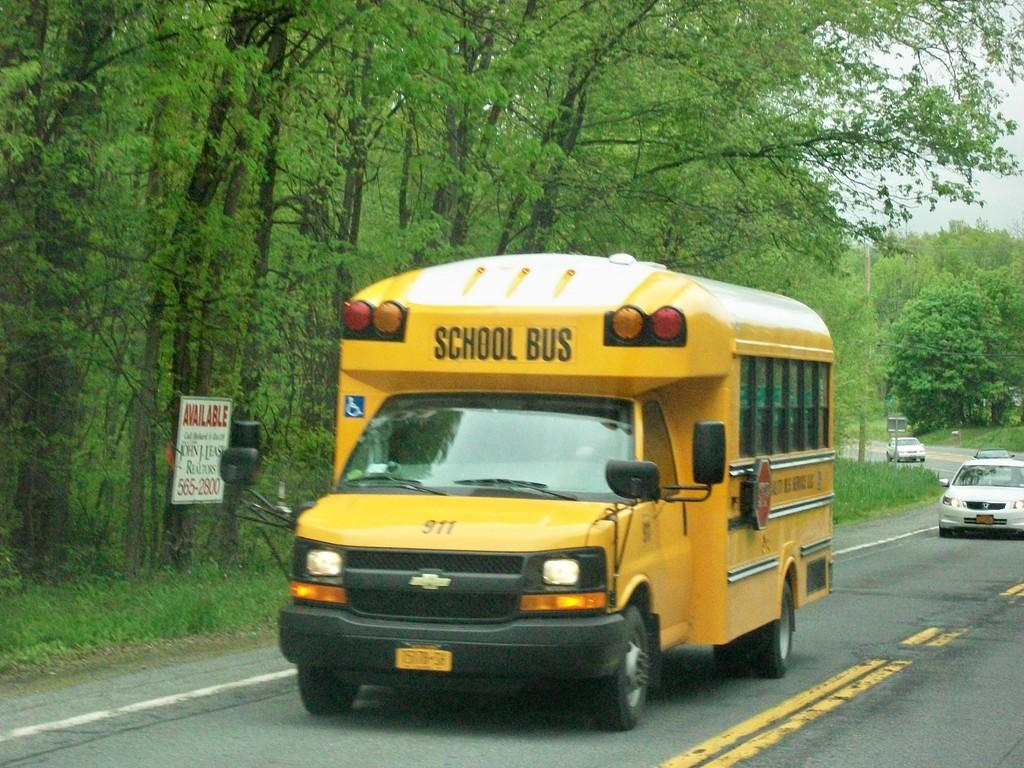What can be seen on the road in the image? There are many vehicles on the road in the image. What type of vegetation is present alongside the road? There are trees on both sides of the road in the image. What is located to the left in the image? There is a board visible to the left in the image. What is visible in the background of the image? The sky is visible in the background of the image. What type of waste can be seen on the side of the road in the image? There is no waste present on the side of the road in the image. How many pies are visible on the board in the image? There are no pies present on the board in the image. 